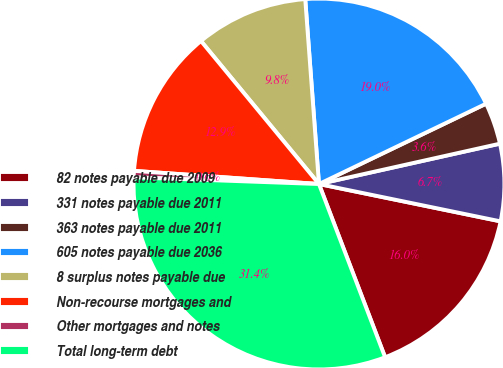Convert chart. <chart><loc_0><loc_0><loc_500><loc_500><pie_chart><fcel>82 notes payable due 2009<fcel>331 notes payable due 2011<fcel>363 notes payable due 2011<fcel>605 notes payable due 2036<fcel>8 surplus notes payable due<fcel>Non-recourse mortgages and<fcel>Other mortgages and notes<fcel>Total long-term debt<nl><fcel>15.97%<fcel>6.72%<fcel>3.64%<fcel>19.05%<fcel>9.8%<fcel>12.89%<fcel>0.56%<fcel>31.38%<nl></chart> 